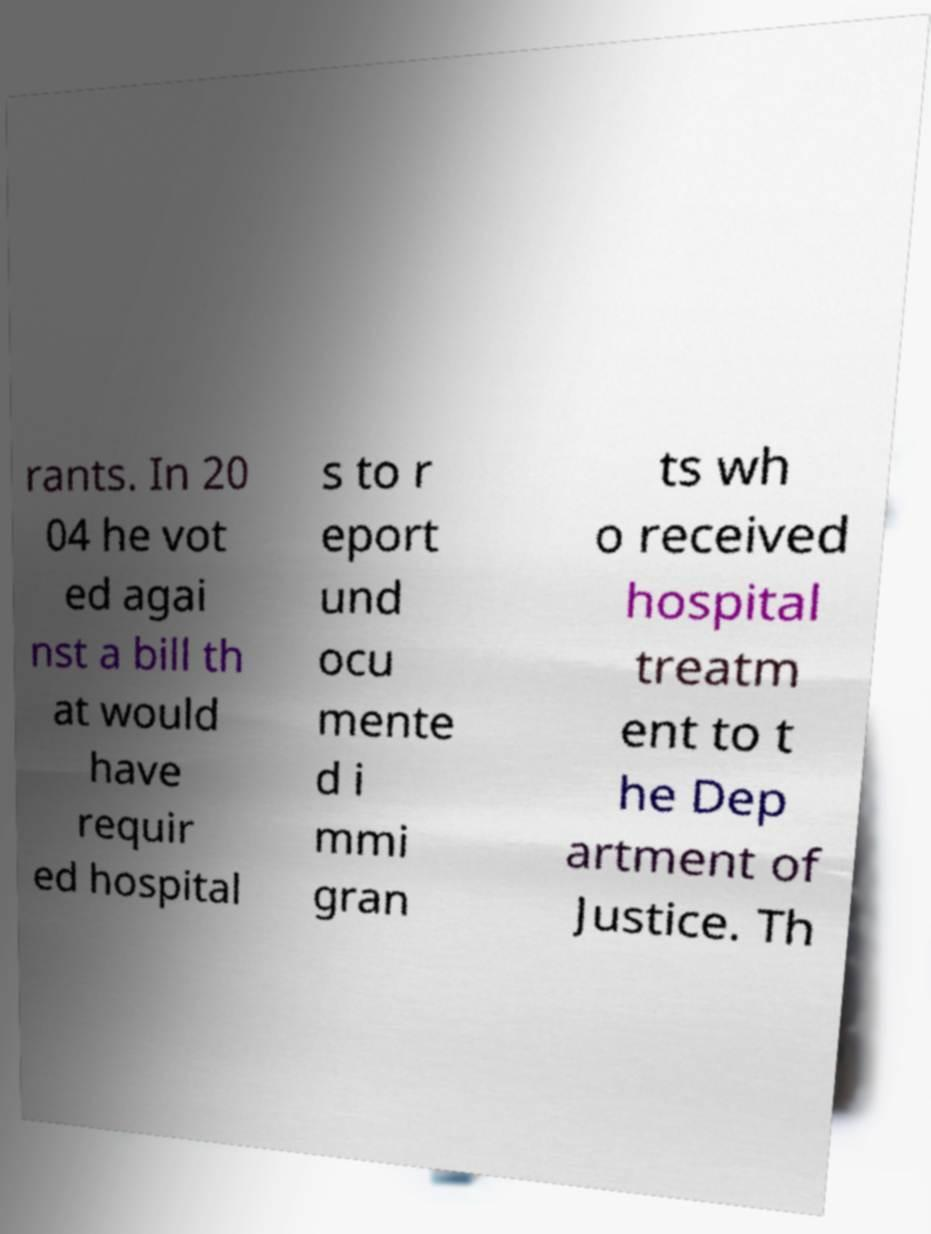I need the written content from this picture converted into text. Can you do that? rants. In 20 04 he vot ed agai nst a bill th at would have requir ed hospital s to r eport und ocu mente d i mmi gran ts wh o received hospital treatm ent to t he Dep artment of Justice. Th 